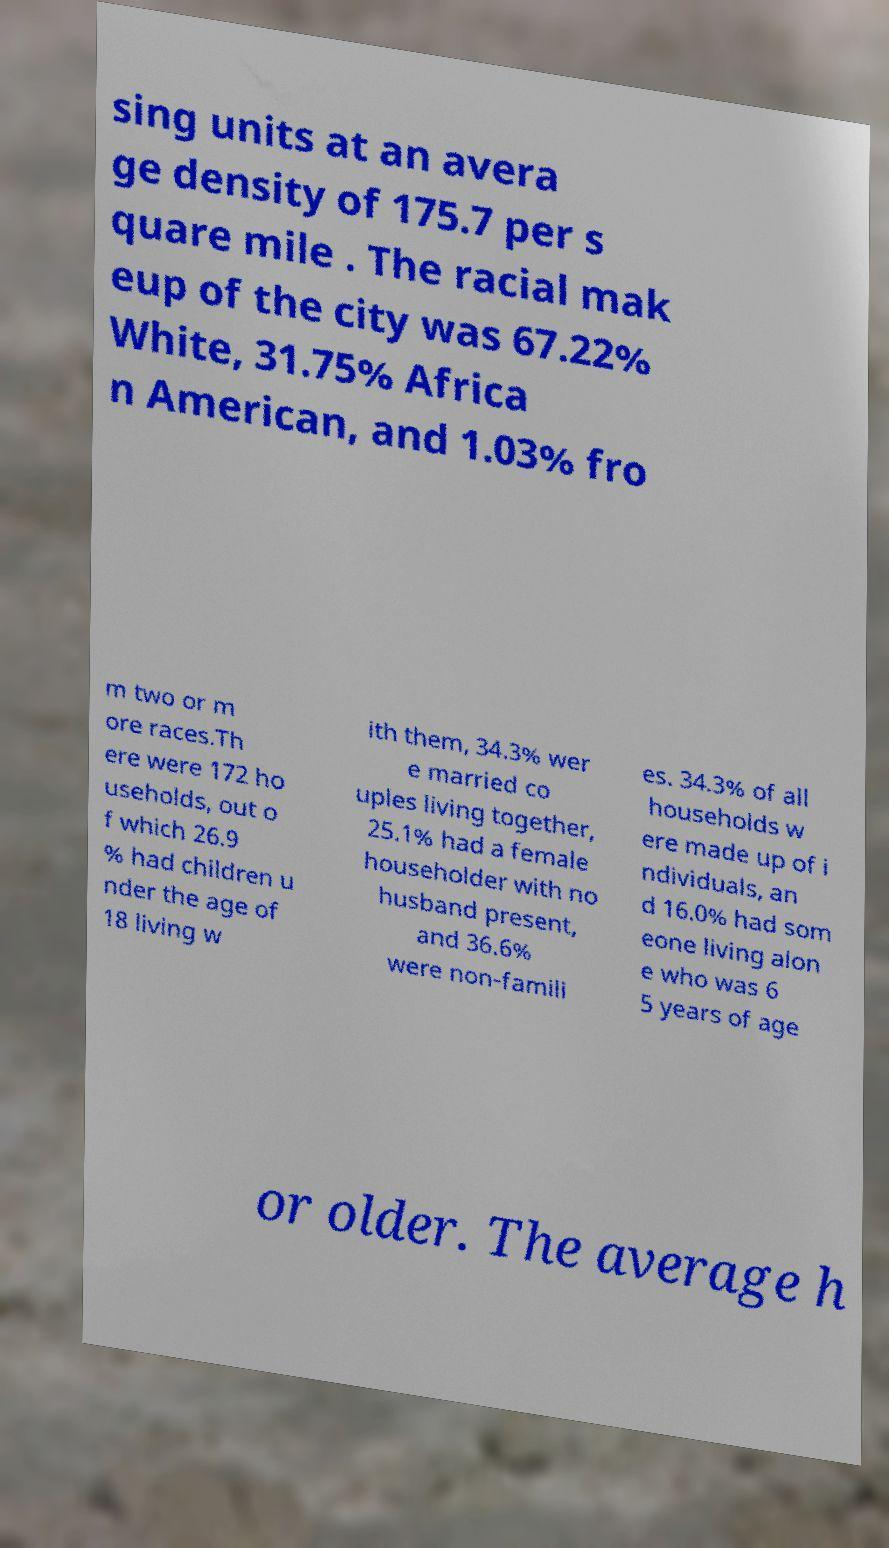Please read and relay the text visible in this image. What does it say? sing units at an avera ge density of 175.7 per s quare mile . The racial mak eup of the city was 67.22% White, 31.75% Africa n American, and 1.03% fro m two or m ore races.Th ere were 172 ho useholds, out o f which 26.9 % had children u nder the age of 18 living w ith them, 34.3% wer e married co uples living together, 25.1% had a female householder with no husband present, and 36.6% were non-famili es. 34.3% of all households w ere made up of i ndividuals, an d 16.0% had som eone living alon e who was 6 5 years of age or older. The average h 